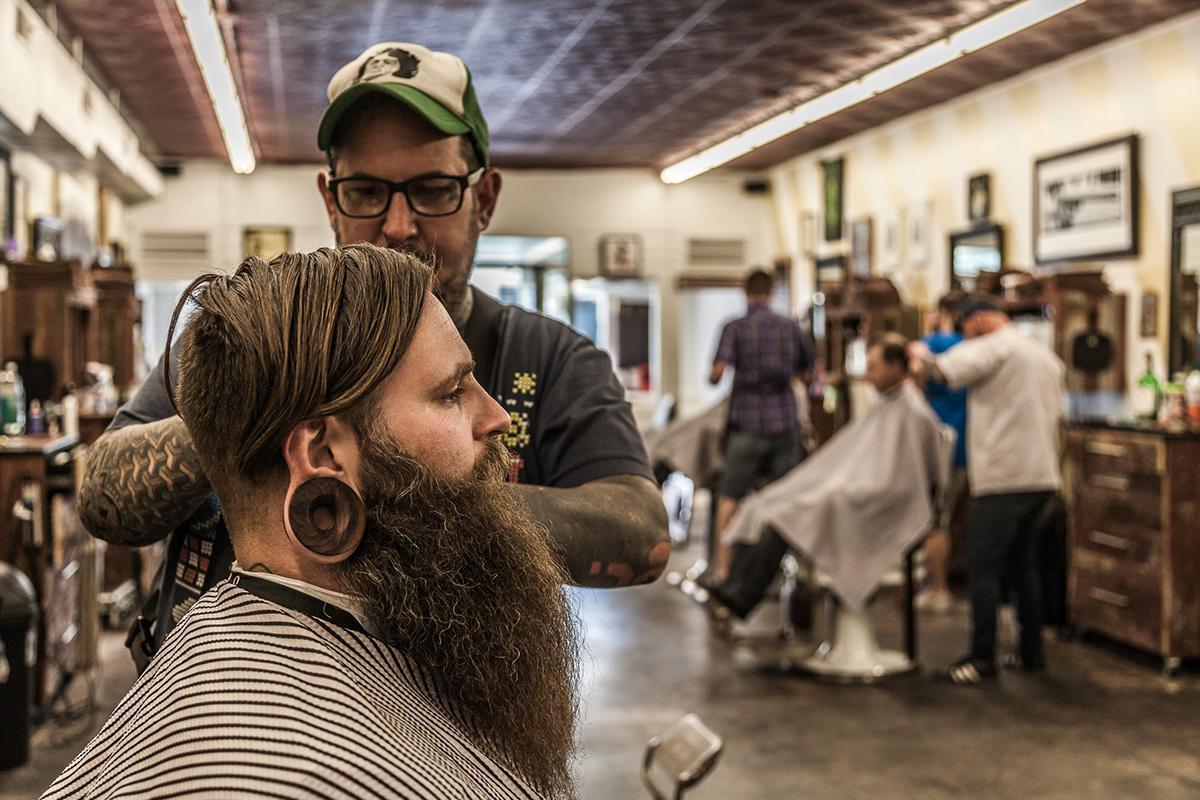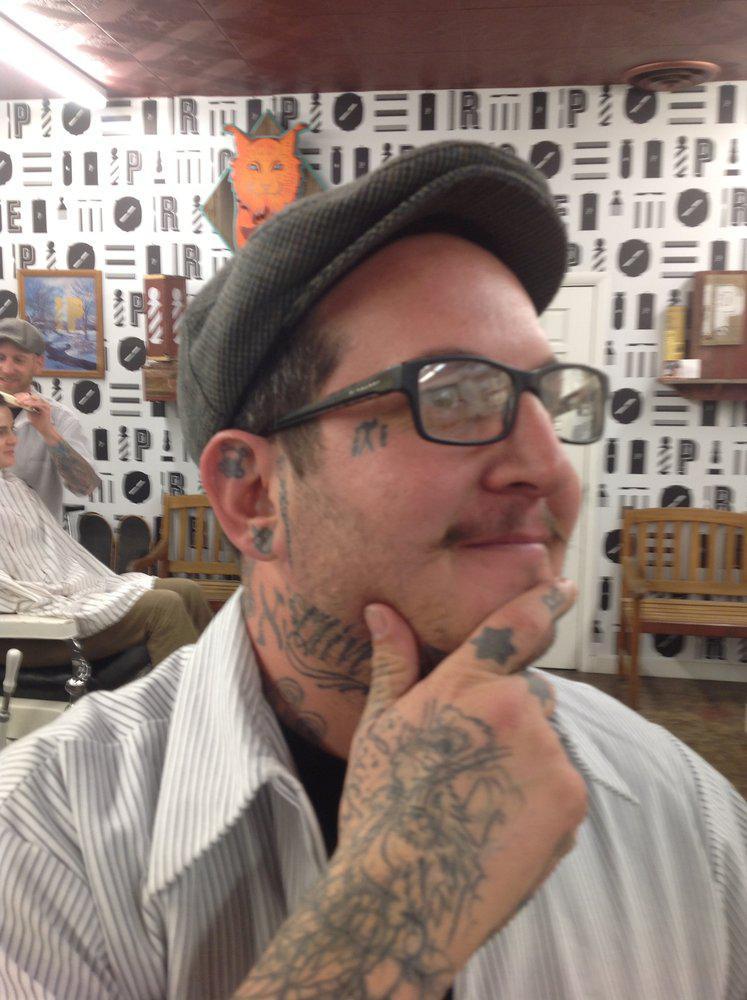The first image is the image on the left, the second image is the image on the right. Given the left and right images, does the statement "Someone is wearing a hat in both images." hold true? Answer yes or no. Yes. The first image is the image on the left, the second image is the image on the right. Analyze the images presented: Is the assertion "IN at least one image there are two men in a row getting their cut." valid? Answer yes or no. No. 